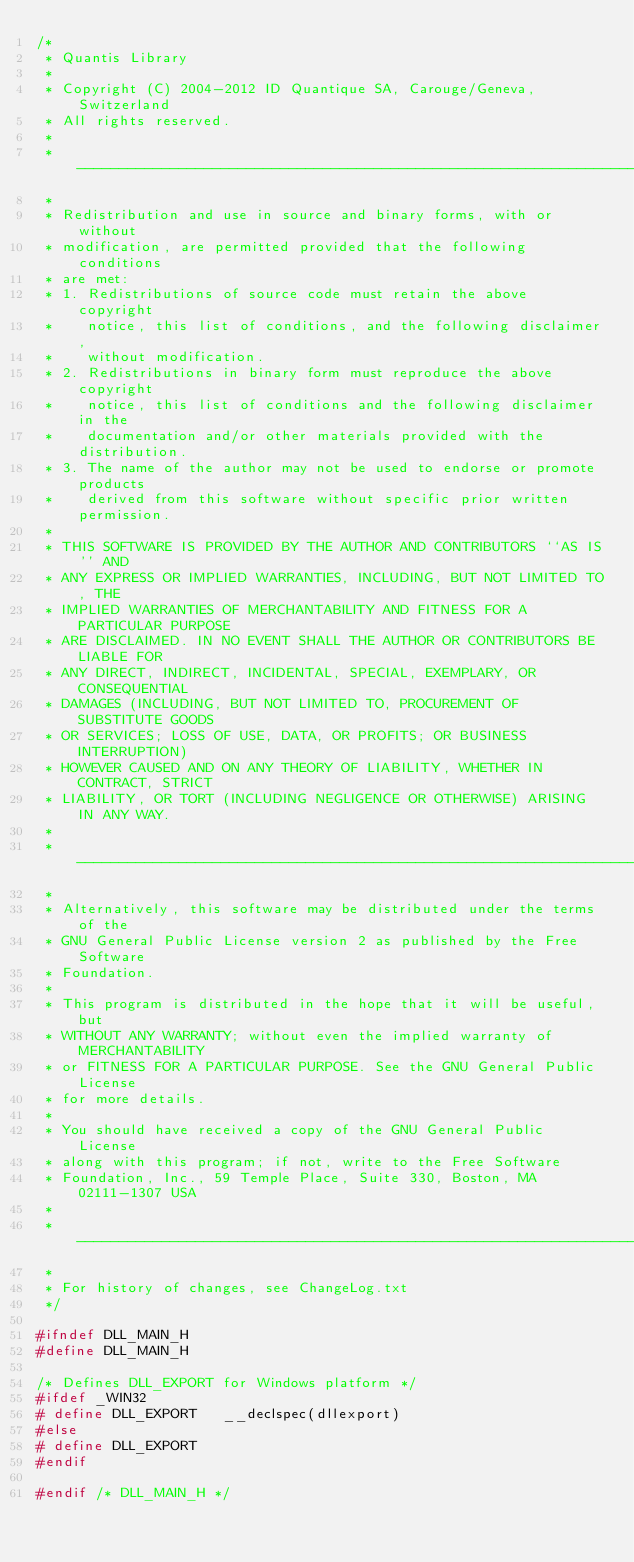<code> <loc_0><loc_0><loc_500><loc_500><_C_>/*
 * Quantis Library
 *
 * Copyright (C) 2004-2012 ID Quantique SA, Carouge/Geneva, Switzerland
 * All rights reserved.
 *
 * ----------------------------------------------------------------------------
 *
 * Redistribution and use in source and binary forms, with or without
 * modification, are permitted provided that the following conditions
 * are met:
 * 1. Redistributions of source code must retain the above copyright
 *    notice, this list of conditions, and the following disclaimer,
 *    without modification.
 * 2. Redistributions in binary form must reproduce the above copyright
 *    notice, this list of conditions and the following disclaimer in the
 *    documentation and/or other materials provided with the distribution.
 * 3. The name of the author may not be used to endorse or promote products
 *    derived from this software without specific prior written permission.
 *
 * THIS SOFTWARE IS PROVIDED BY THE AUTHOR AND CONTRIBUTORS ``AS IS'' AND
 * ANY EXPRESS OR IMPLIED WARRANTIES, INCLUDING, BUT NOT LIMITED TO, THE
 * IMPLIED WARRANTIES OF MERCHANTABILITY AND FITNESS FOR A PARTICULAR PURPOSE
 * ARE DISCLAIMED. IN NO EVENT SHALL THE AUTHOR OR CONTRIBUTORS BE LIABLE FOR
 * ANY DIRECT, INDIRECT, INCIDENTAL, SPECIAL, EXEMPLARY, OR CONSEQUENTIAL
 * DAMAGES (INCLUDING, BUT NOT LIMITED TO, PROCUREMENT OF SUBSTITUTE GOODS
 * OR SERVICES; LOSS OF USE, DATA, OR PROFITS; OR BUSINESS INTERRUPTION)
 * HOWEVER CAUSED AND ON ANY THEORY OF LIABILITY, WHETHER IN CONTRACT, STRICT
 * LIABILITY, OR TORT (INCLUDING NEGLIGENCE OR OTHERWISE) ARISING IN ANY WAY.
 *
 * ----------------------------------------------------------------------------
 *
 * Alternatively, this software may be distributed under the terms of the
 * GNU General Public License version 2 as published by the Free Software 
 * Foundation.
 *
 * This program is distributed in the hope that it will be useful, but
 * WITHOUT ANY WARRANTY; without even the implied warranty of MERCHANTABILITY
 * or FITNESS FOR A PARTICULAR PURPOSE. See the GNU General Public License
 * for more details.
 *
 * You should have received a copy of the GNU General Public License
 * along with this program; if not, write to the Free Software
 * Foundation, Inc., 59 Temple Place, Suite 330, Boston, MA  02111-1307 USA
 *
 * ----------------------------------------------------------------------------
 *
 * For history of changes, see ChangeLog.txt
 */

#ifndef DLL_MAIN_H
#define DLL_MAIN_H

/* Defines DLL_EXPORT for Windows platform */
#ifdef _WIN32
# define DLL_EXPORT   __declspec(dllexport)
#else
# define DLL_EXPORT
#endif

#endif /* DLL_MAIN_H */
</code> 